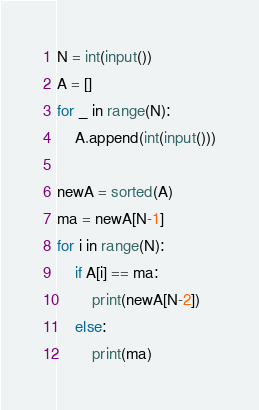Convert code to text. <code><loc_0><loc_0><loc_500><loc_500><_Python_>N = int(input())
A = []
for _ in range(N):
    A.append(int(input()))

newA = sorted(A)
ma = newA[N-1]
for i in range(N):
    if A[i] == ma:
        print(newA[N-2])
    else:
        print(ma)</code> 